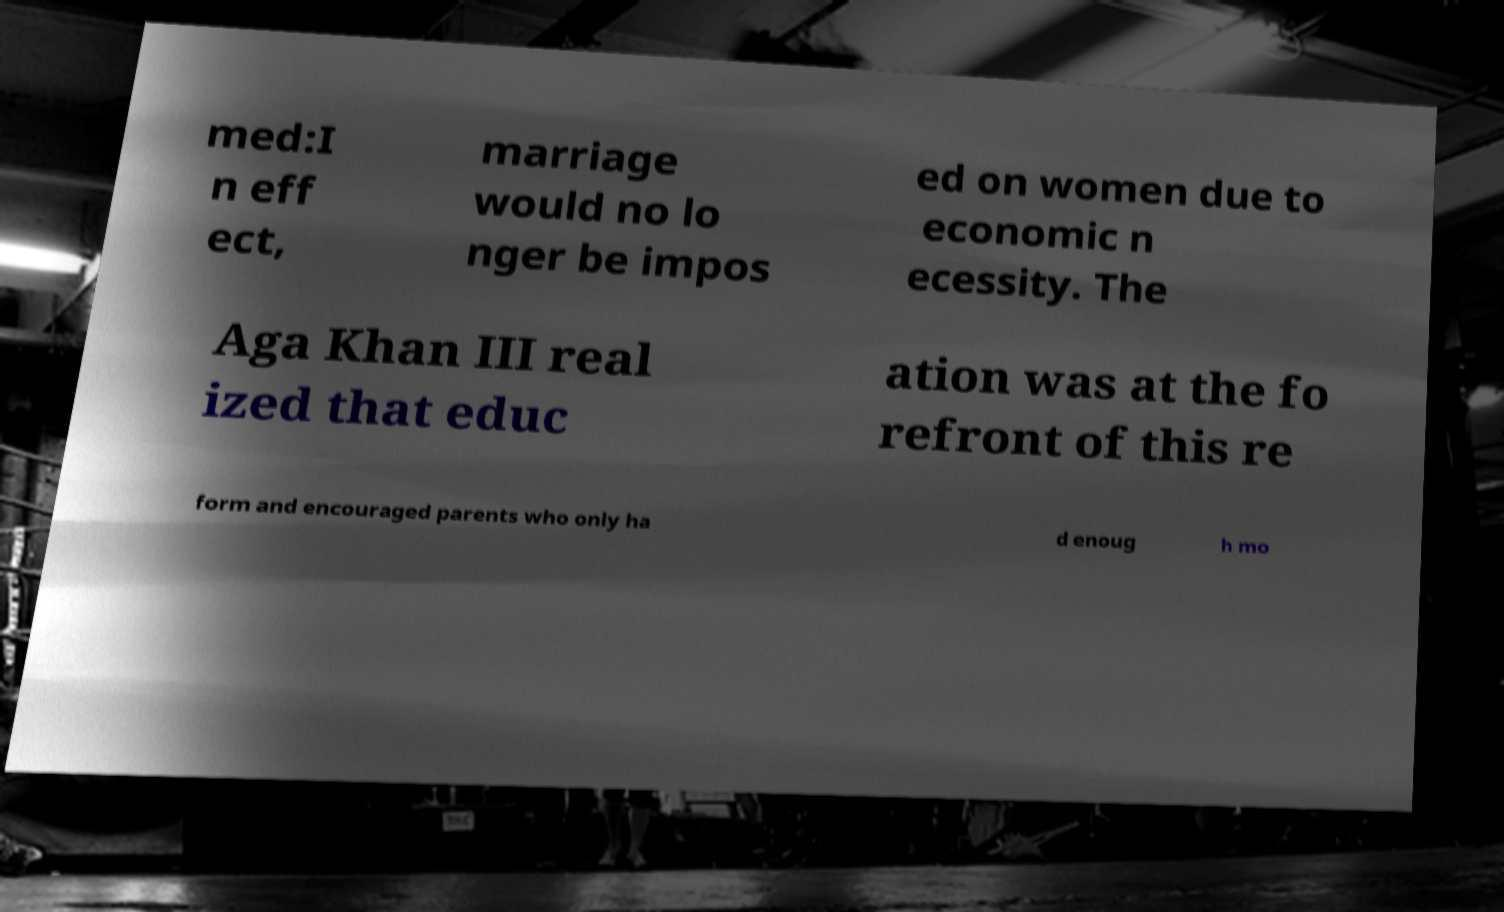Please identify and transcribe the text found in this image. med:I n eff ect, marriage would no lo nger be impos ed on women due to economic n ecessity. The Aga Khan III real ized that educ ation was at the fo refront of this re form and encouraged parents who only ha d enoug h mo 